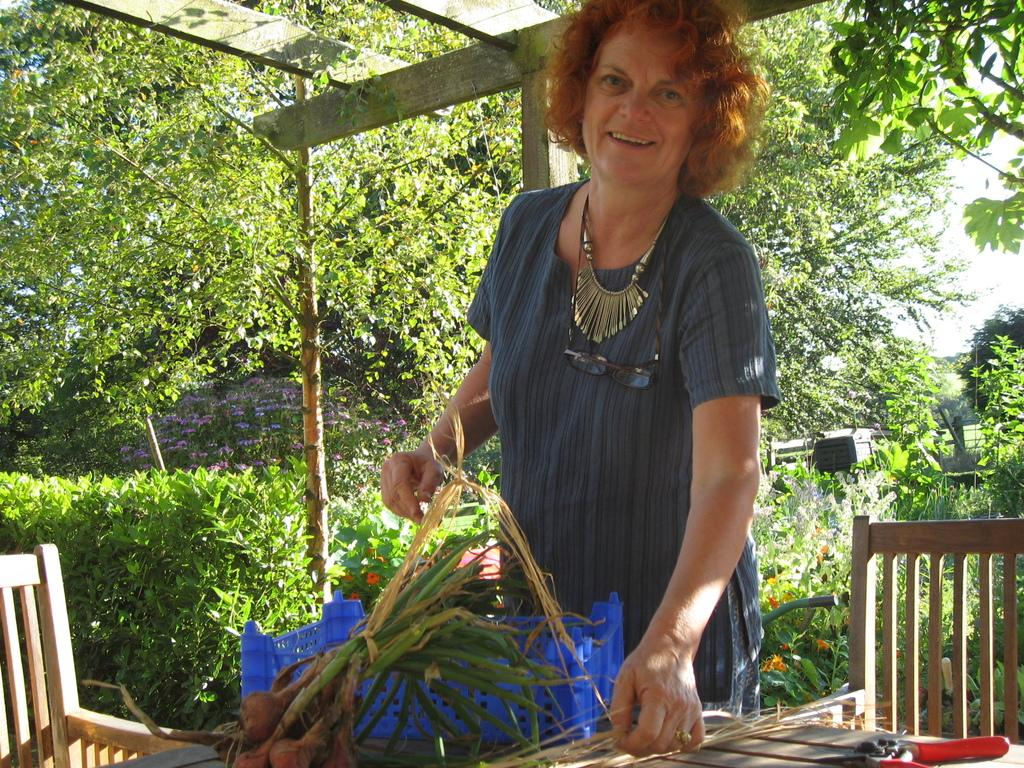What objects are in the foreground of the image? There are chairs, a table, food items, a basket, and a woman in the foreground of the image. What can be seen in the middle of the image? There are trees, a wooden pole, flowers, plants, and a railing in the middle of the image. What is visible at the top of the image? Sky is visible at the top of the image. What type of plough is being used to harvest the flowers in the image? There is no plough present in the image, and the flowers are not being harvested. What unit of measurement is being used to determine the height of the railing in the image? There is no indication of a specific unit of measurement being used to determine the height of the railing in the image. 